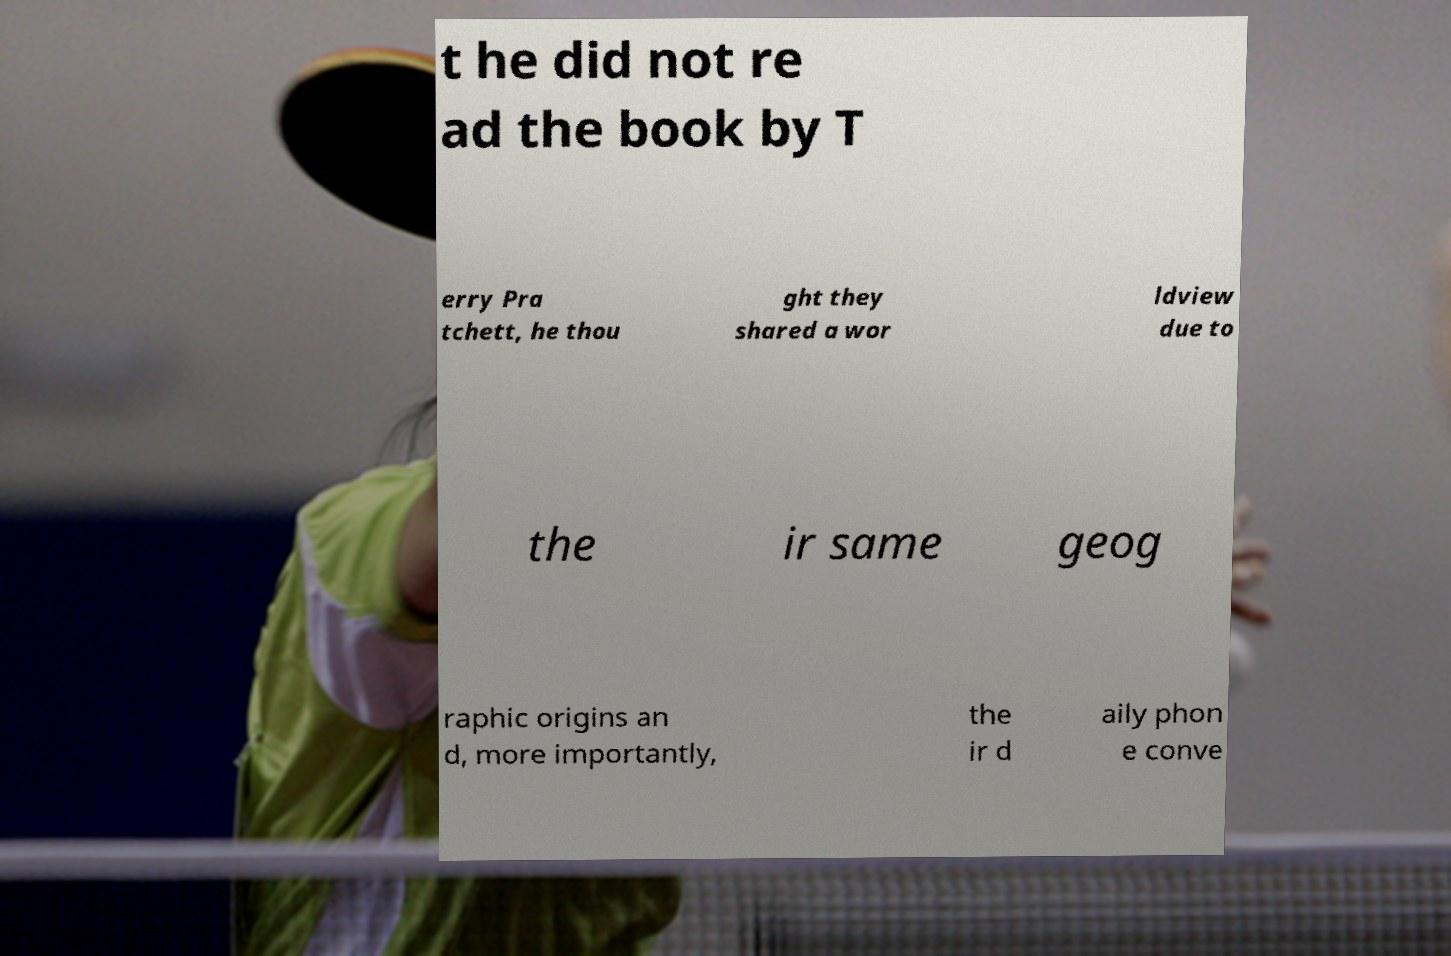Could you assist in decoding the text presented in this image and type it out clearly? t he did not re ad the book by T erry Pra tchett, he thou ght they shared a wor ldview due to the ir same geog raphic origins an d, more importantly, the ir d aily phon e conve 